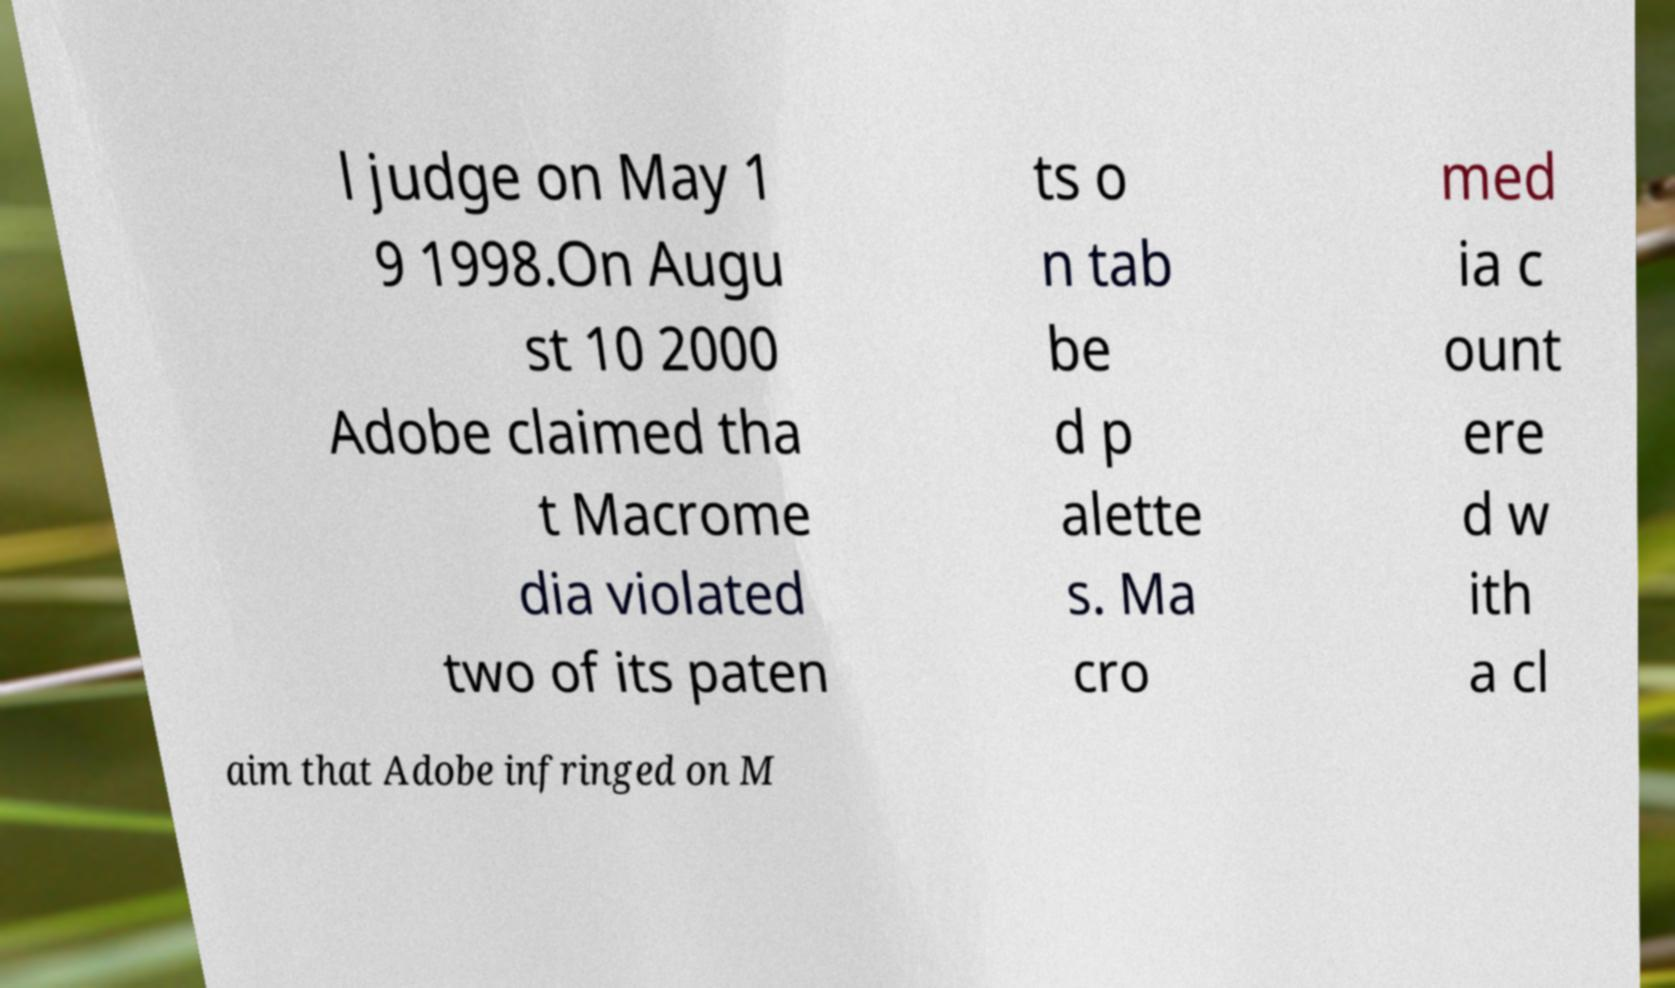What messages or text are displayed in this image? I need them in a readable, typed format. l judge on May 1 9 1998.On Augu st 10 2000 Adobe claimed tha t Macrome dia violated two of its paten ts o n tab be d p alette s. Ma cro med ia c ount ere d w ith a cl aim that Adobe infringed on M 